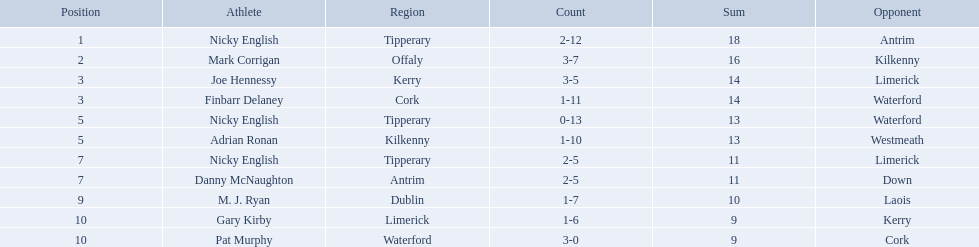Which of the following players were ranked in the bottom 5? Nicky English, Danny McNaughton, M. J. Ryan, Gary Kirby, Pat Murphy. Of these, whose tallies were not 2-5? M. J. Ryan, Gary Kirby, Pat Murphy. From the above three, which one scored more than 9 total points? M. J. Ryan. What numbers are in the total column? 18, 16, 14, 14, 13, 13, 11, 11, 10, 9, 9. What row has the number 10 in the total column? 9, M. J. Ryan, Dublin, 1-7, 10, Laois. What name is in the player column for this row? M. J. Ryan. Who are all the players? Nicky English, Mark Corrigan, Joe Hennessy, Finbarr Delaney, Nicky English, Adrian Ronan, Nicky English, Danny McNaughton, M. J. Ryan, Gary Kirby, Pat Murphy. How many points did they receive? 18, 16, 14, 14, 13, 13, 11, 11, 10, 9, 9. And which player received 10 points? M. J. Ryan. 